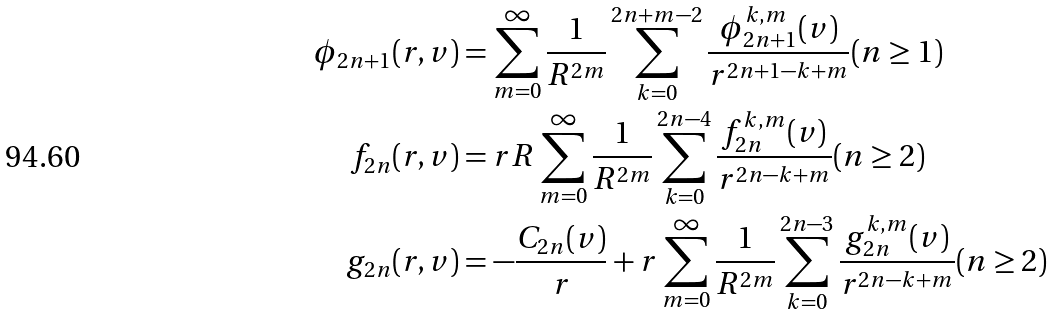<formula> <loc_0><loc_0><loc_500><loc_500>\phi _ { 2 n + 1 } ( r , v ) & = \sum _ { m = 0 } ^ { \infty } \frac { 1 } { R ^ { 2 m } } \sum _ { k = 0 } ^ { 2 n + m - 2 } \frac { \phi _ { 2 n + 1 } ^ { k , m } ( v ) } { r ^ { 2 n + 1 - k + m } } ( n \geq 1 ) \\ f _ { 2 n } ( r , v ) & = r R \sum _ { m = 0 } ^ { \infty } \frac { 1 } { R ^ { 2 m } } \sum _ { k = 0 } ^ { 2 n - 4 } \frac { f _ { 2 n } ^ { k , m } ( v ) } { r ^ { 2 n - k + m } } ( n \geq 2 ) \\ g _ { 2 n } ( r , v ) & = - \frac { C _ { 2 n } ( v ) } { r } + r \sum _ { m = 0 } ^ { \infty } \frac { 1 } { R ^ { 2 m } } \sum _ { k = 0 } ^ { 2 n - 3 } \frac { g _ { 2 n } ^ { k , m } ( v ) } { r ^ { 2 n - k + m } } ( n \geq 2 ) \\</formula> 